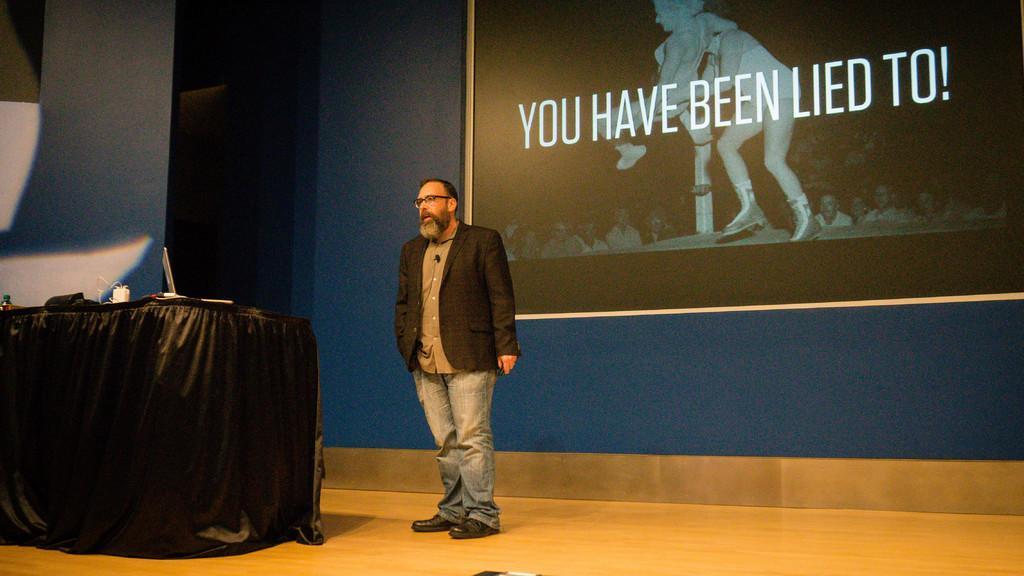Can you describe this image briefly? There is a person standing and wearing specs is speaking. On the left side there is a table with black cloth. On that there is a laptop and many other items. In the background there is a screen with something written on that. Also there are some people on the screen. 